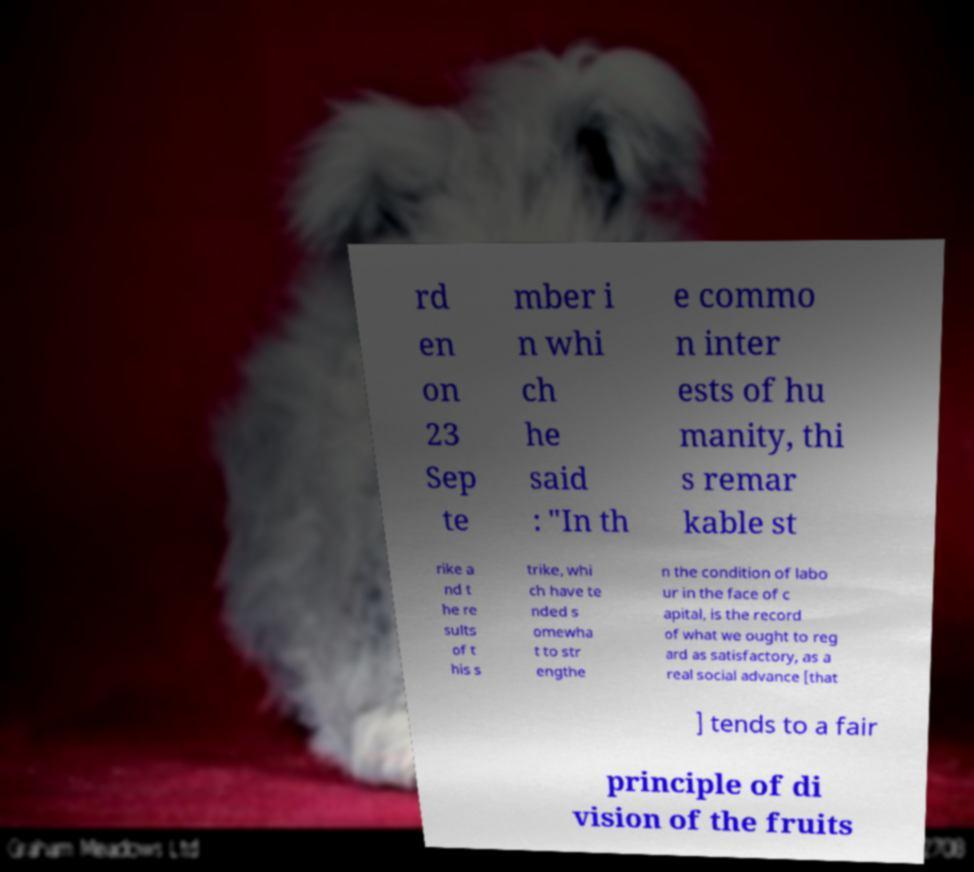For documentation purposes, I need the text within this image transcribed. Could you provide that? rd en on 23 Sep te mber i n whi ch he said : "In th e commo n inter ests of hu manity, thi s remar kable st rike a nd t he re sults of t his s trike, whi ch have te nded s omewha t to str engthe n the condition of labo ur in the face of c apital, is the record of what we ought to reg ard as satisfactory, as a real social advance [that ] tends to a fair principle of di vision of the fruits 